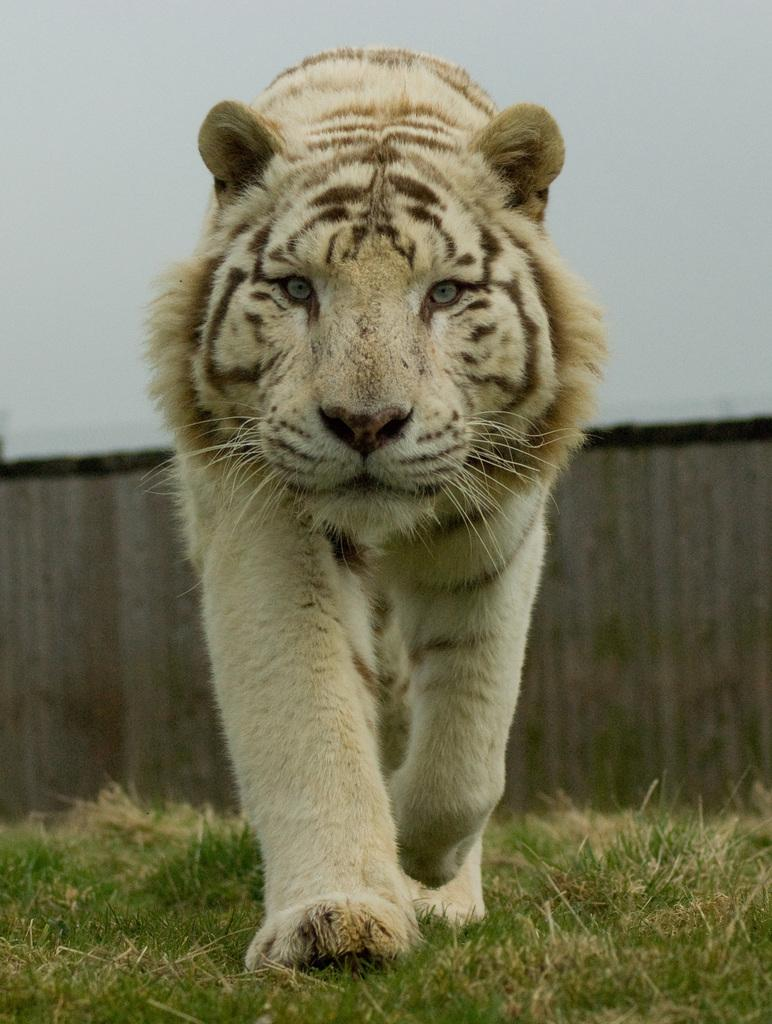What animal is the main subject of the picture? There is a tiger in the picture. What type of terrain is visible at the bottom of the picture? There is grass at the bottom of the picture. Can you describe the background of the picture? The background of the picture is blurry. What type of food is the tiger holding in its paws in the picture? There is no food visible in the picture; the tiger is not holding anything in its paws. 